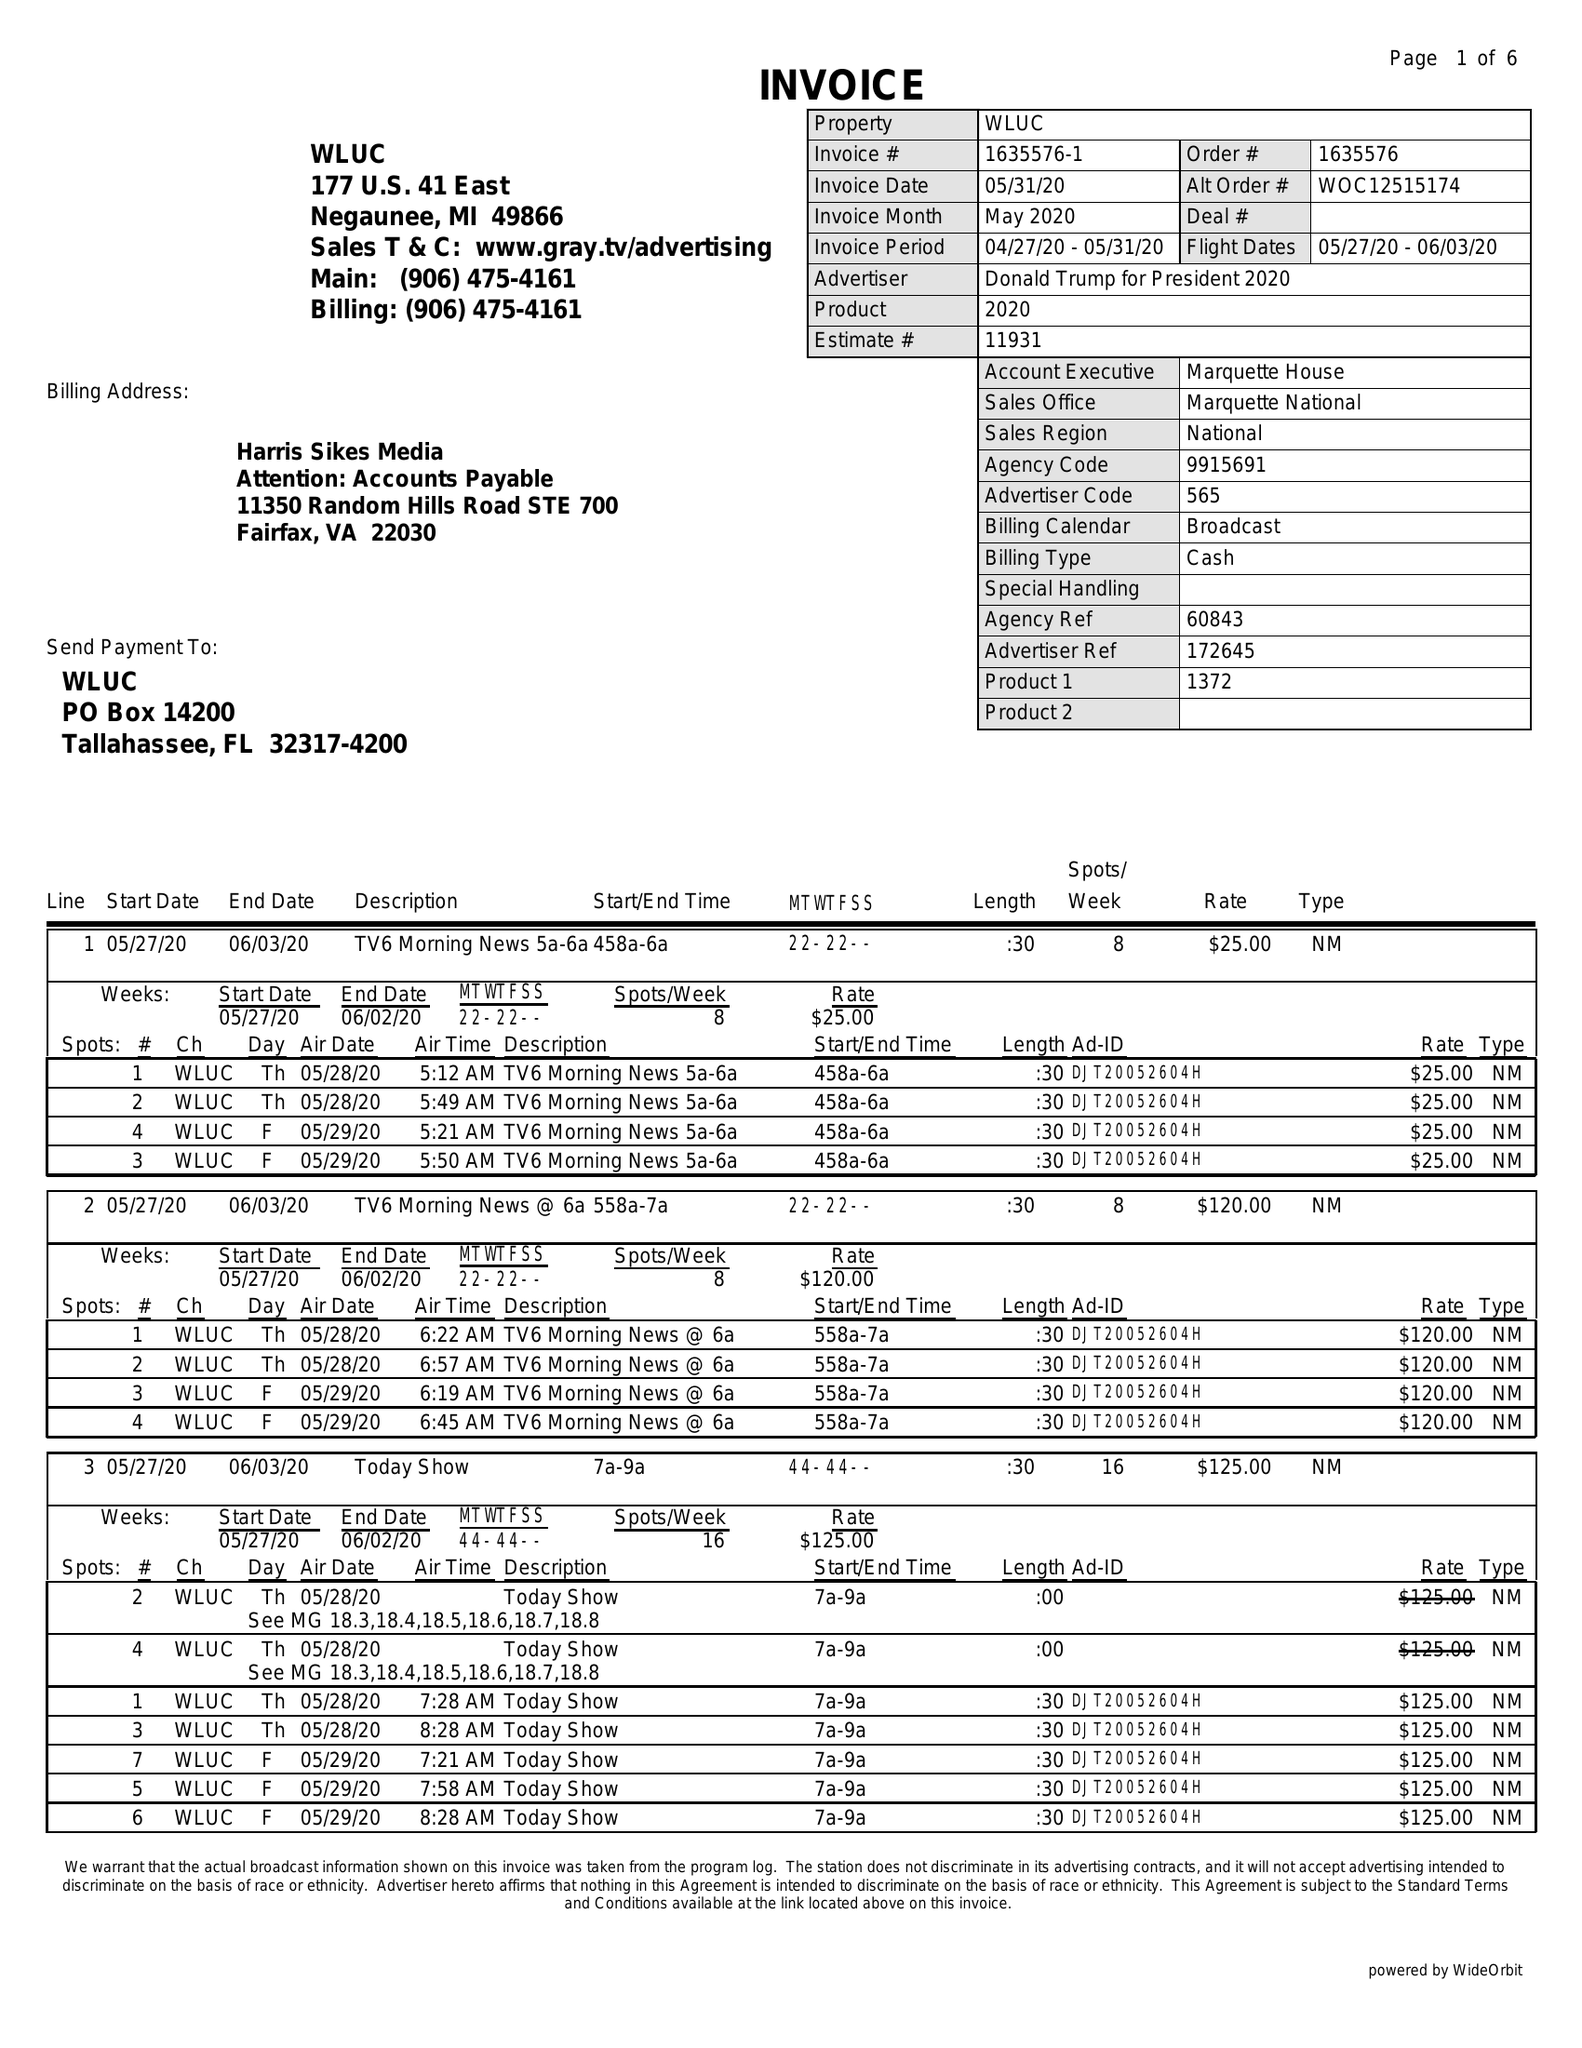What is the value for the flight_from?
Answer the question using a single word or phrase. 05/27/20 